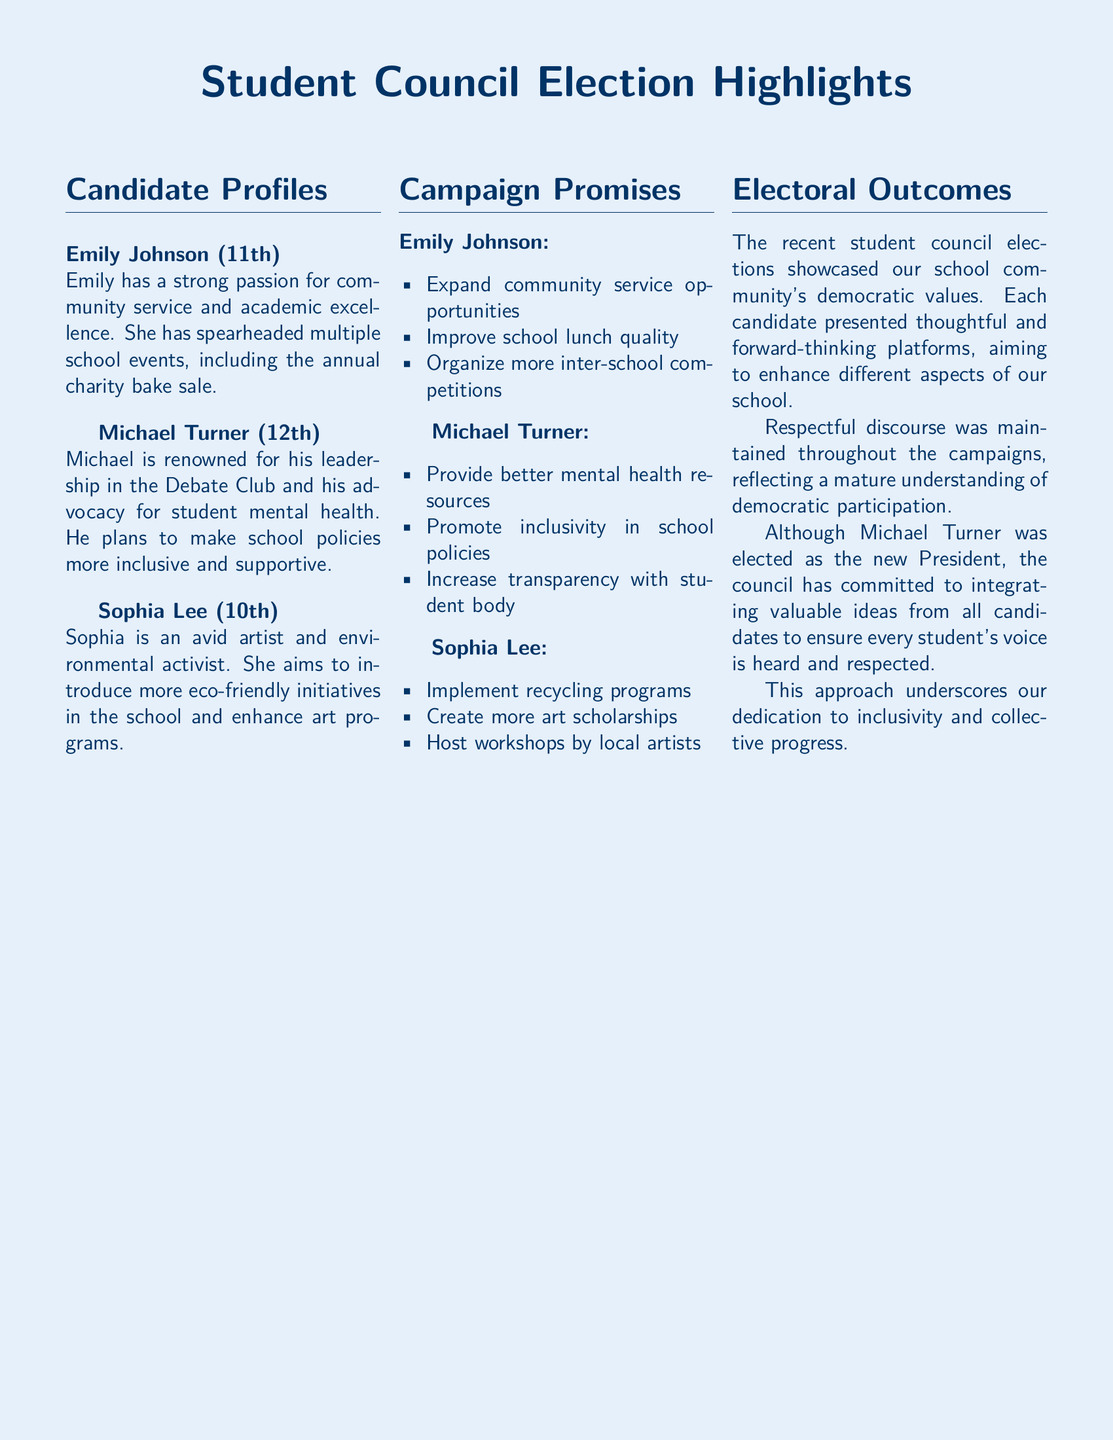What is the name of the candidate who is an environmental activist? Sophia Lee's profile mentions her as an environmental activist, which corresponds to her candidacy.
Answer: Sophia Lee What grade is Michael Turner in? The document states that Michael Turner is a 12th grader, as indicated in his candidate profile.
Answer: 12th Which candidate proposed to improve school lunch quality? Emily Johnson listed improving school lunch quality as part of her campaign promises, highlighting her focus.
Answer: Emily Johnson How many candidates are featured in the document? The document presents profiles for three candidates, indicating the competitive nature of the elections.
Answer: Three What is one of Sophia Lee's campaign promises? The document outlines Sophia Lee's campaign promise to implement recycling programs, showcasing her focus on environmental issues.
Answer: Implement recycling programs Who was elected as the new President? The document indicates that Michael Turner was elected President following the student council elections.
Answer: Michael Turner What aspect of student life does Michael Turner want to enhance? Michael Turner aims to provide better mental health resources, emphasizing the importance of student well-being.
Answer: Mental health resources How did the candidates maintain the election process? The electoral outcomes section reflects a commitment to maintaining respectful discourse throughout the election campaigns.
Answer: Respectful discourse What is the main theme of the document? The document emphasizes student council elections, conveying democratic values and candidate engagement within the school community.
Answer: Student council elections 